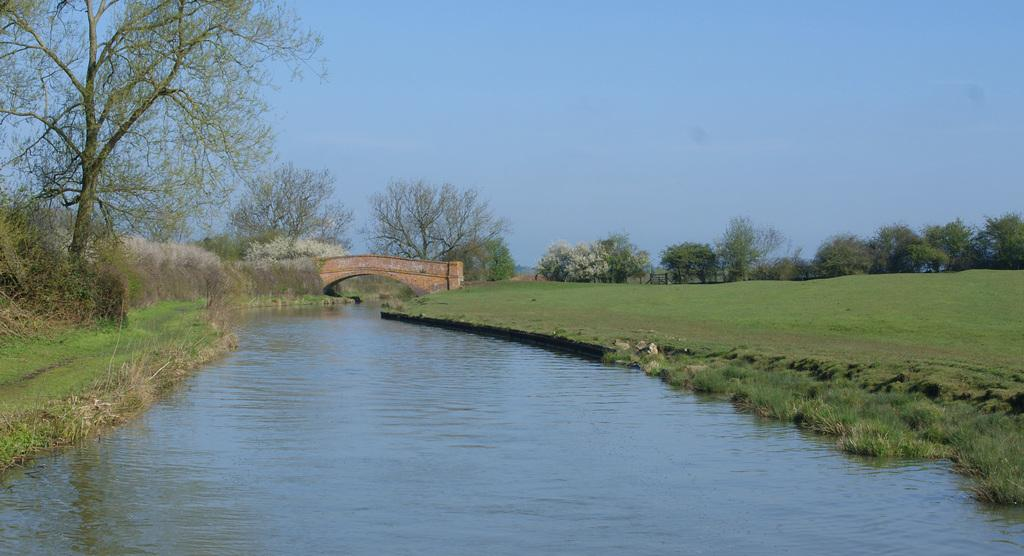What type of vegetation is located beside the water in the image? There is grass beside the water in the image. What other types of vegetation can be seen near the water? There are plants and trees near the water. What structure is visible in the distance in the image? There is a bridge visible in the distance. What color is the sky in the background of the image? The background of the image includes a blue sky. How many fans are visible in the image? There are no fans present in the image. What type of eggs can be seen near the water in the image? There are no eggs present in the image. 